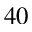<formula> <loc_0><loc_0><loc_500><loc_500>^ { 4 0 }</formula> 